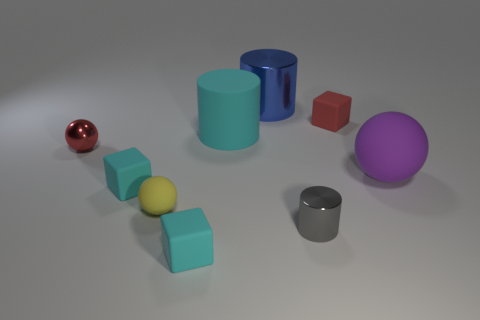Add 1 rubber things. How many objects exist? 10 Subtract all small balls. How many balls are left? 1 Subtract 2 cubes. How many cubes are left? 1 Subtract 0 red cylinders. How many objects are left? 9 Subtract all spheres. How many objects are left? 6 Subtract all red cylinders. Subtract all brown cubes. How many cylinders are left? 3 Subtract all yellow spheres. How many gray cylinders are left? 1 Subtract all yellow matte spheres. Subtract all purple matte objects. How many objects are left? 7 Add 6 large cylinders. How many large cylinders are left? 8 Add 1 tiny matte blocks. How many tiny matte blocks exist? 4 